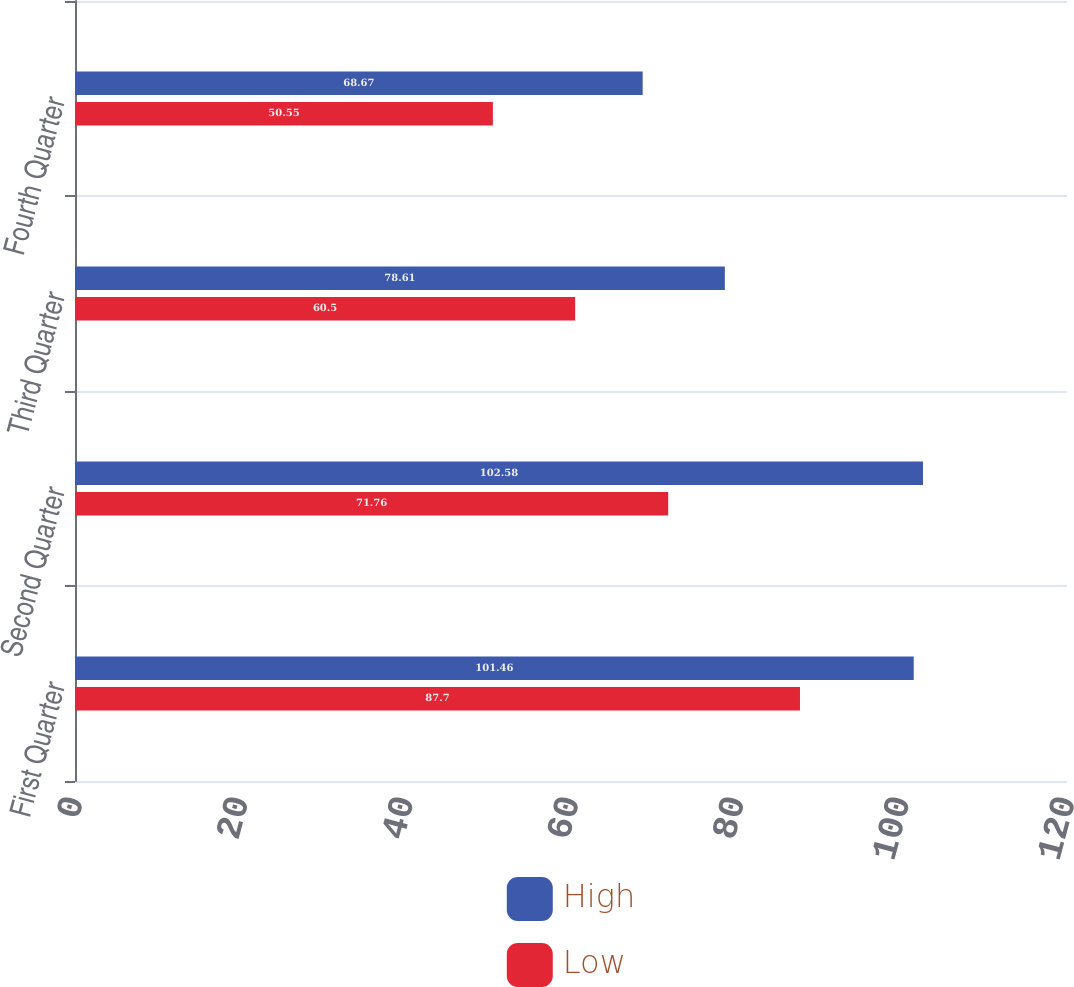Convert chart. <chart><loc_0><loc_0><loc_500><loc_500><stacked_bar_chart><ecel><fcel>First Quarter<fcel>Second Quarter<fcel>Third Quarter<fcel>Fourth Quarter<nl><fcel>High<fcel>101.46<fcel>102.58<fcel>78.61<fcel>68.67<nl><fcel>Low<fcel>87.7<fcel>71.76<fcel>60.5<fcel>50.55<nl></chart> 